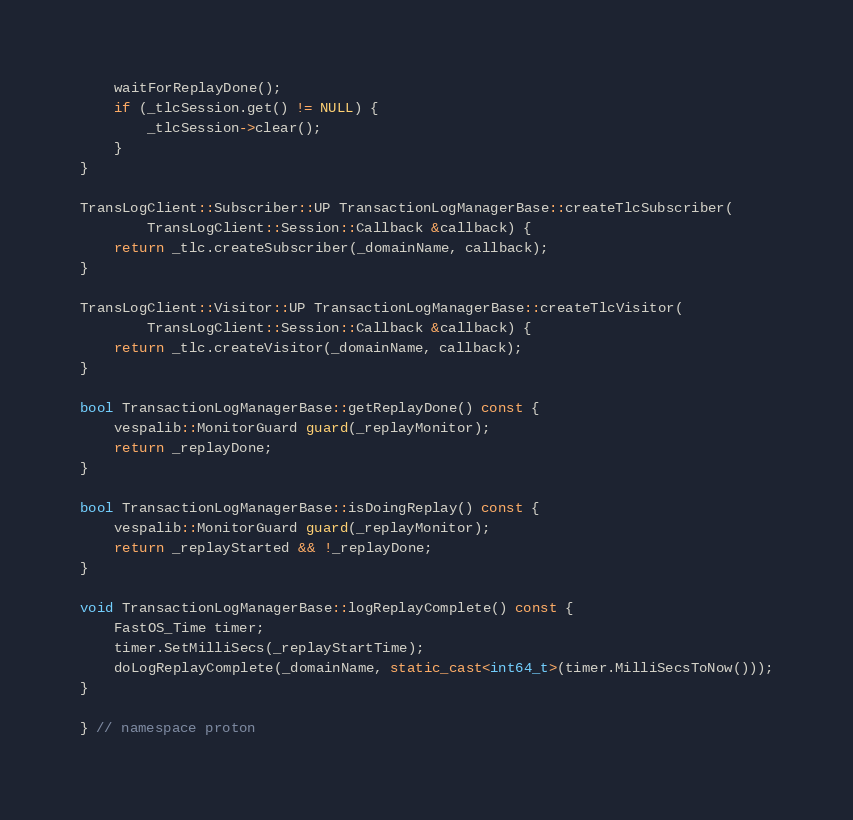Convert code to text. <code><loc_0><loc_0><loc_500><loc_500><_C++_>    waitForReplayDone();
    if (_tlcSession.get() != NULL) {
        _tlcSession->clear();
    }
}

TransLogClient::Subscriber::UP TransactionLogManagerBase::createTlcSubscriber(
        TransLogClient::Session::Callback &callback) {
    return _tlc.createSubscriber(_domainName, callback);
}

TransLogClient::Visitor::UP TransactionLogManagerBase::createTlcVisitor(
        TransLogClient::Session::Callback &callback) {
    return _tlc.createVisitor(_domainName, callback);
}

bool TransactionLogManagerBase::getReplayDone() const {
    vespalib::MonitorGuard guard(_replayMonitor);
    return _replayDone;
}

bool TransactionLogManagerBase::isDoingReplay() const {
    vespalib::MonitorGuard guard(_replayMonitor);
    return _replayStarted && !_replayDone;
}

void TransactionLogManagerBase::logReplayComplete() const {
    FastOS_Time timer;
    timer.SetMilliSecs(_replayStartTime);
    doLogReplayComplete(_domainName, static_cast<int64_t>(timer.MilliSecsToNow()));
}

} // namespace proton
</code> 